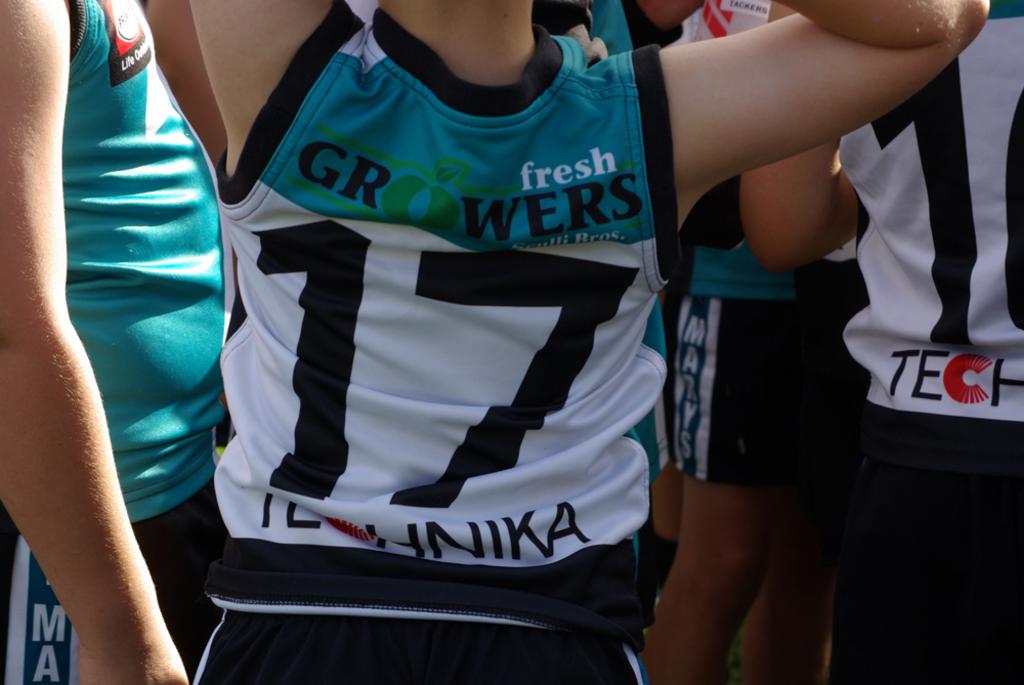What is his shirt number?
Ensure brevity in your answer.  17. 